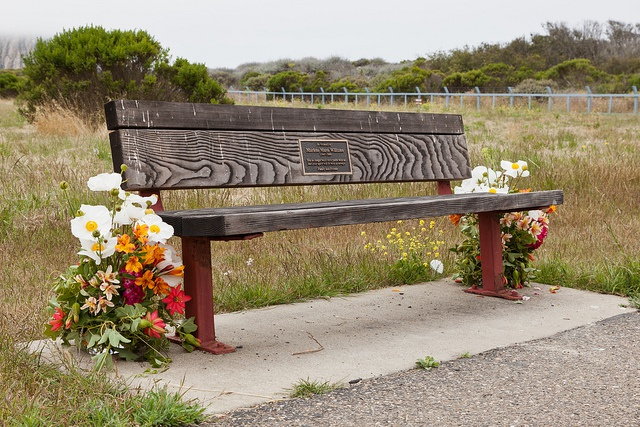Describe the objects in this image and their specific colors. I can see bench in white, gray, black, darkgray, and maroon tones, potted plant in white, lightgray, olive, and black tones, and potted plant in white, black, olive, and lightgray tones in this image. 